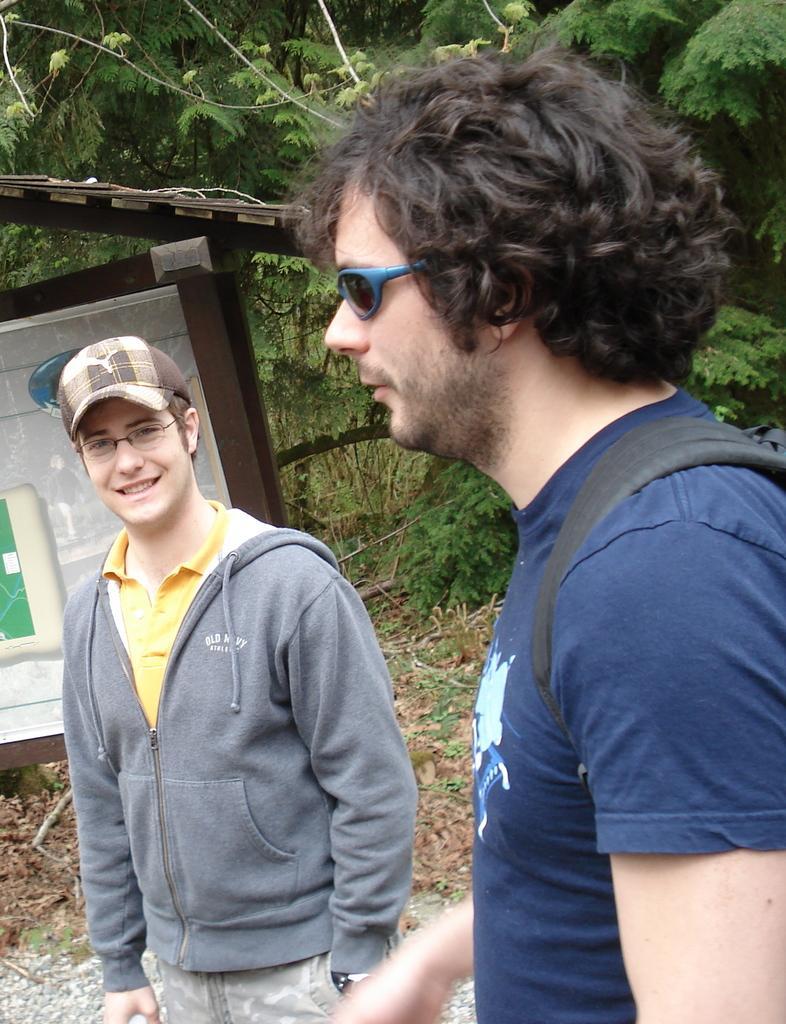Could you give a brief overview of what you see in this image? There is a person in violet color t-shirt standing and speaking and there is another person who is in gray color coat standing on the ground. In the background, there is a hoarding attached to the poles which are on the ground, there are trees and there is grass on the ground. 